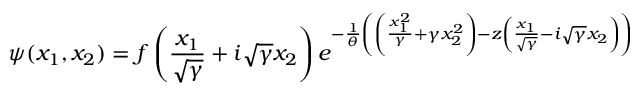<formula> <loc_0><loc_0><loc_500><loc_500>\psi ( x _ { 1 } , x _ { 2 } ) = f \left ( \frac { x _ { 1 } } { \sqrt { \gamma } } + i \sqrt { \gamma } x _ { 2 } \right ) e ^ { - \frac { 1 } { \theta } \left ( \left ( \frac { x _ { 1 } ^ { 2 } } { \gamma } + \gamma x _ { 2 } ^ { 2 } \right ) - z \left ( \frac { x _ { 1 } } { \sqrt { \gamma } } - i \sqrt { \gamma } x _ { 2 } \right ) \right ) }</formula> 